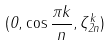Convert formula to latex. <formula><loc_0><loc_0><loc_500><loc_500>( 0 , \cos \frac { \pi k } { n } , \zeta _ { 2 n } ^ { k } )</formula> 